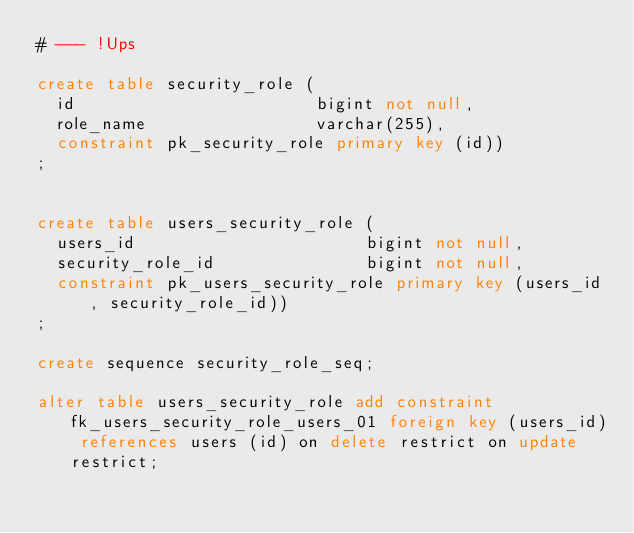<code> <loc_0><loc_0><loc_500><loc_500><_SQL_># --- !Ups

create table security_role (
  id                        bigint not null,
  role_name                 varchar(255),
  constraint pk_security_role primary key (id))
;


create table users_security_role (
  users_id                       bigint not null,
  security_role_id               bigint not null,
  constraint pk_users_security_role primary key (users_id, security_role_id))
;

create sequence security_role_seq;

alter table users_security_role add constraint fk_users_security_role_users_01 foreign key (users_id) references users (id) on delete restrict on update restrict;
</code> 